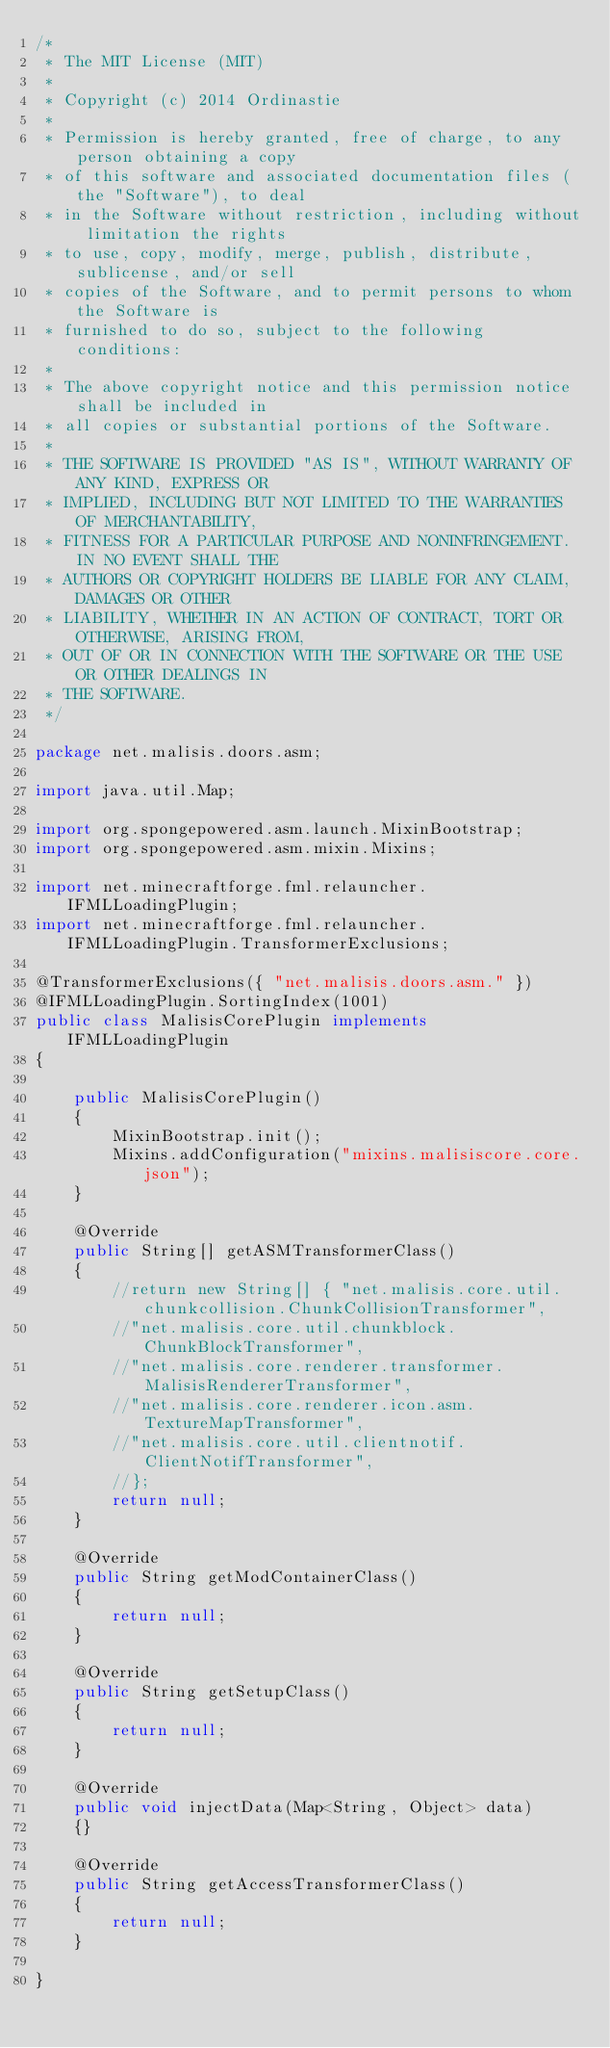Convert code to text. <code><loc_0><loc_0><loc_500><loc_500><_Java_>/*
 * The MIT License (MIT)
 *
 * Copyright (c) 2014 Ordinastie
 *
 * Permission is hereby granted, free of charge, to any person obtaining a copy
 * of this software and associated documentation files (the "Software"), to deal
 * in the Software without restriction, including without limitation the rights
 * to use, copy, modify, merge, publish, distribute, sublicense, and/or sell
 * copies of the Software, and to permit persons to whom the Software is
 * furnished to do so, subject to the following conditions:
 *
 * The above copyright notice and this permission notice shall be included in
 * all copies or substantial portions of the Software.
 *
 * THE SOFTWARE IS PROVIDED "AS IS", WITHOUT WARRANTY OF ANY KIND, EXPRESS OR
 * IMPLIED, INCLUDING BUT NOT LIMITED TO THE WARRANTIES OF MERCHANTABILITY,
 * FITNESS FOR A PARTICULAR PURPOSE AND NONINFRINGEMENT. IN NO EVENT SHALL THE
 * AUTHORS OR COPYRIGHT HOLDERS BE LIABLE FOR ANY CLAIM, DAMAGES OR OTHER
 * LIABILITY, WHETHER IN AN ACTION OF CONTRACT, TORT OR OTHERWISE, ARISING FROM,
 * OUT OF OR IN CONNECTION WITH THE SOFTWARE OR THE USE OR OTHER DEALINGS IN
 * THE SOFTWARE.
 */

package net.malisis.doors.asm;

import java.util.Map;

import org.spongepowered.asm.launch.MixinBootstrap;
import org.spongepowered.asm.mixin.Mixins;

import net.minecraftforge.fml.relauncher.IFMLLoadingPlugin;
import net.minecraftforge.fml.relauncher.IFMLLoadingPlugin.TransformerExclusions;

@TransformerExclusions({ "net.malisis.doors.asm." })
@IFMLLoadingPlugin.SortingIndex(1001)
public class MalisisCorePlugin implements IFMLLoadingPlugin
{

	public MalisisCorePlugin()
	{
		MixinBootstrap.init();
		Mixins.addConfiguration("mixins.malisiscore.core.json");
	}

	@Override
	public String[] getASMTransformerClass()
	{
		//return new String[] { "net.malisis.core.util.chunkcollision.ChunkCollisionTransformer",
		//"net.malisis.core.util.chunkblock.ChunkBlockTransformer",
		//"net.malisis.core.renderer.transformer.MalisisRendererTransformer",
		//"net.malisis.core.renderer.icon.asm.TextureMapTransformer",
		//"net.malisis.core.util.clientnotif.ClientNotifTransformer",
		//};
		return null;
	}

	@Override
	public String getModContainerClass()
	{
		return null;
	}

	@Override
	public String getSetupClass()
	{
		return null;
	}

	@Override
	public void injectData(Map<String, Object> data)
	{}

	@Override
	public String getAccessTransformerClass()
	{
		return null;
	}

}
</code> 